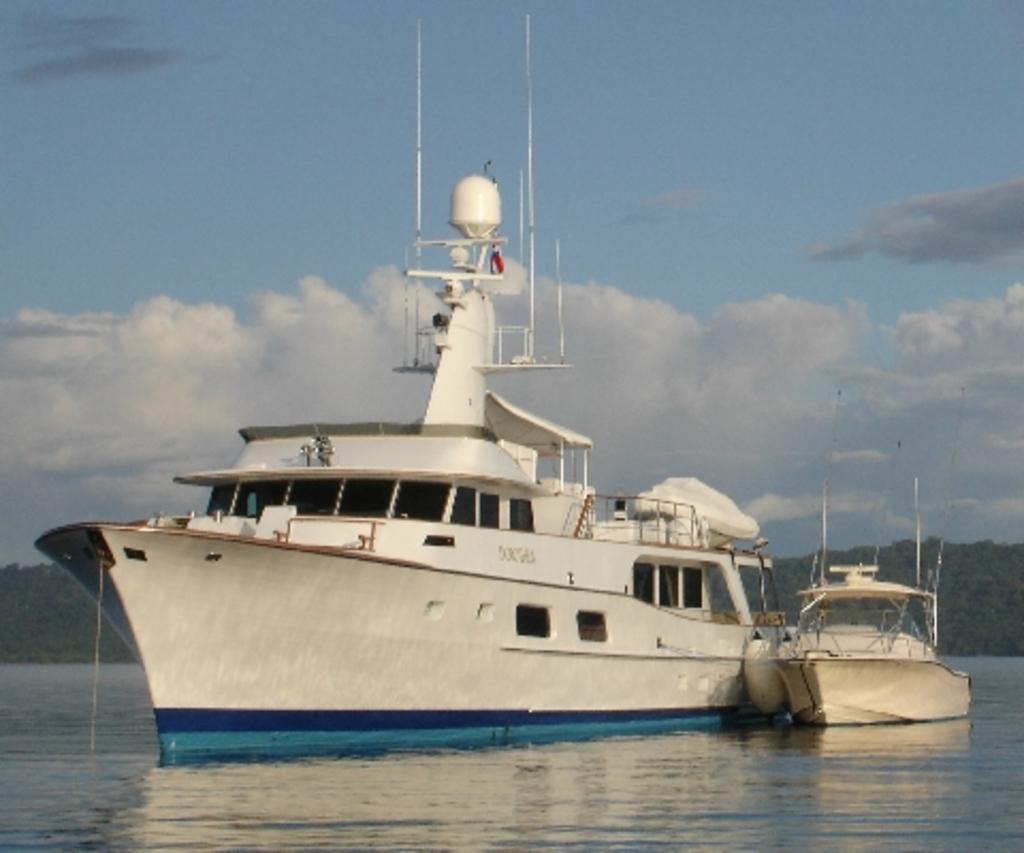Please provide a concise description of this image. In this image there is a ship and a boat on the water , and in the background there are trees,sky. 